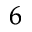Convert formula to latex. <formula><loc_0><loc_0><loc_500><loc_500>^ { 6 }</formula> 